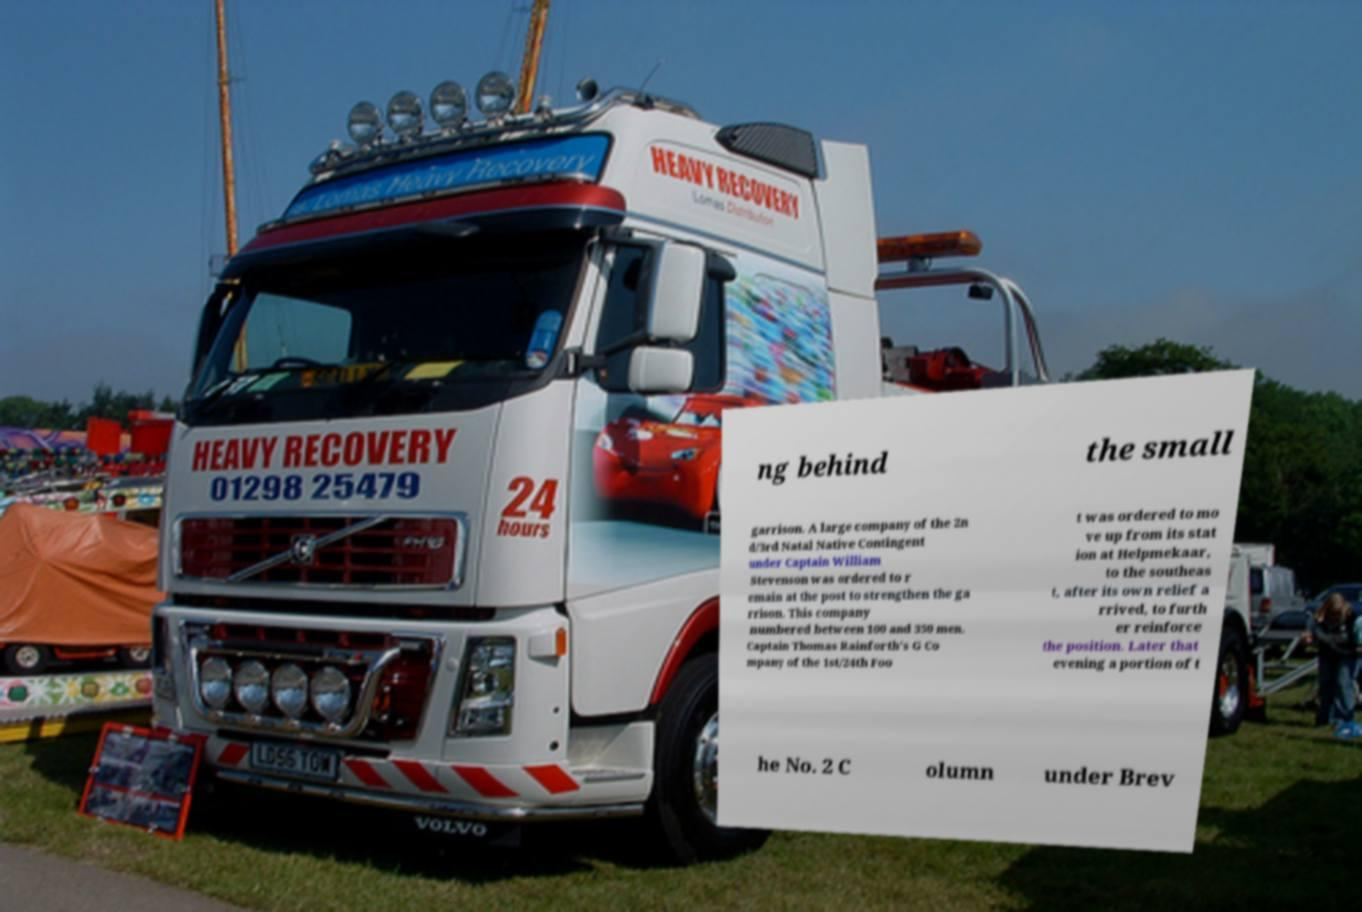There's text embedded in this image that I need extracted. Can you transcribe it verbatim? ng behind the small garrison. A large company of the 2n d/3rd Natal Native Contingent under Captain William Stevenson was ordered to r emain at the post to strengthen the ga rrison. This company numbered between 100 and 350 men. Captain Thomas Rainforth's G Co mpany of the 1st/24th Foo t was ordered to mo ve up from its stat ion at Helpmekaar, to the southeas t, after its own relief a rrived, to furth er reinforce the position. Later that evening a portion of t he No. 2 C olumn under Brev 